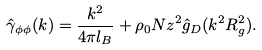<formula> <loc_0><loc_0><loc_500><loc_500>\hat { \gamma } _ { \phi \phi } ( k ) = \frac { k ^ { 2 } } { 4 \pi l _ { B } } + { \rho _ { 0 } } N z ^ { 2 } \hat { g } _ { D } ( k ^ { 2 } R _ { g } ^ { 2 } ) .</formula> 